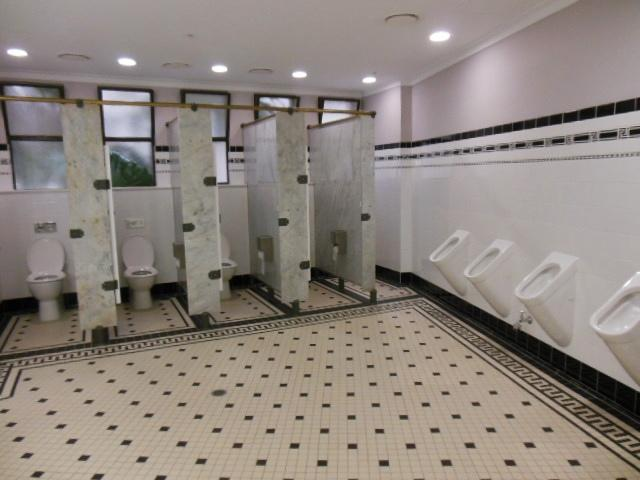What type of location is this?

Choices:
A) residential
B) public
C) private
D) theatrical public 